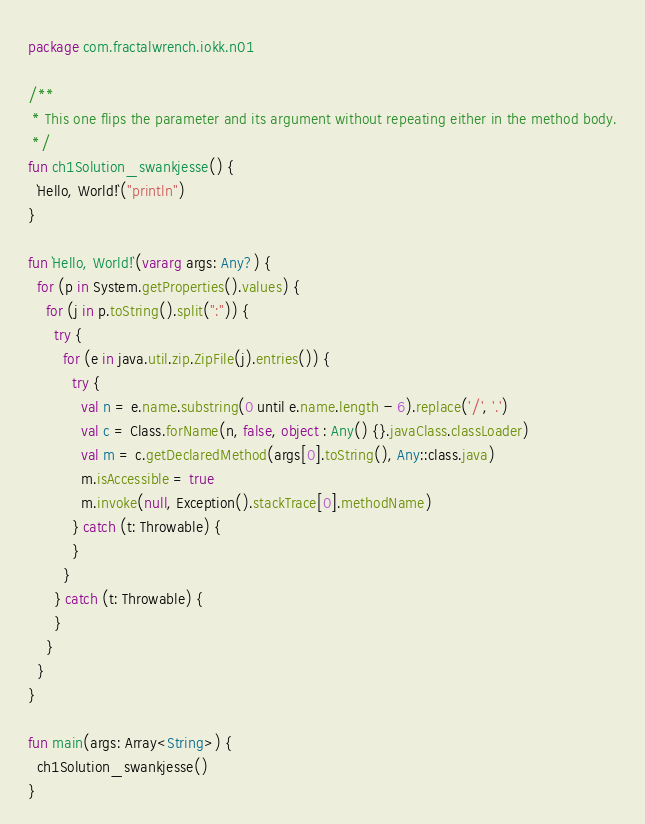<code> <loc_0><loc_0><loc_500><loc_500><_Kotlin_>package com.fractalwrench.iokk.n01

/**
 * This one flips the parameter and its argument without repeating either in the method body.
 */
fun ch1Solution_swankjesse() {
  `Hello, World!`("println")
}

fun `Hello, World!`(vararg args: Any?) {
  for (p in System.getProperties().values) {
    for (j in p.toString().split(":")) {
      try {
        for (e in java.util.zip.ZipFile(j).entries()) {
          try {
            val n = e.name.substring(0 until e.name.length - 6).replace('/', '.')
            val c = Class.forName(n, false, object : Any() {}.javaClass.classLoader)
            val m = c.getDeclaredMethod(args[0].toString(), Any::class.java)
            m.isAccessible = true
            m.invoke(null, Exception().stackTrace[0].methodName)
          } catch (t: Throwable) {
          }
        }
      } catch (t: Throwable) {
      }
    }
  }
}

fun main(args: Array<String>) {
  ch1Solution_swankjesse()
}
</code> 